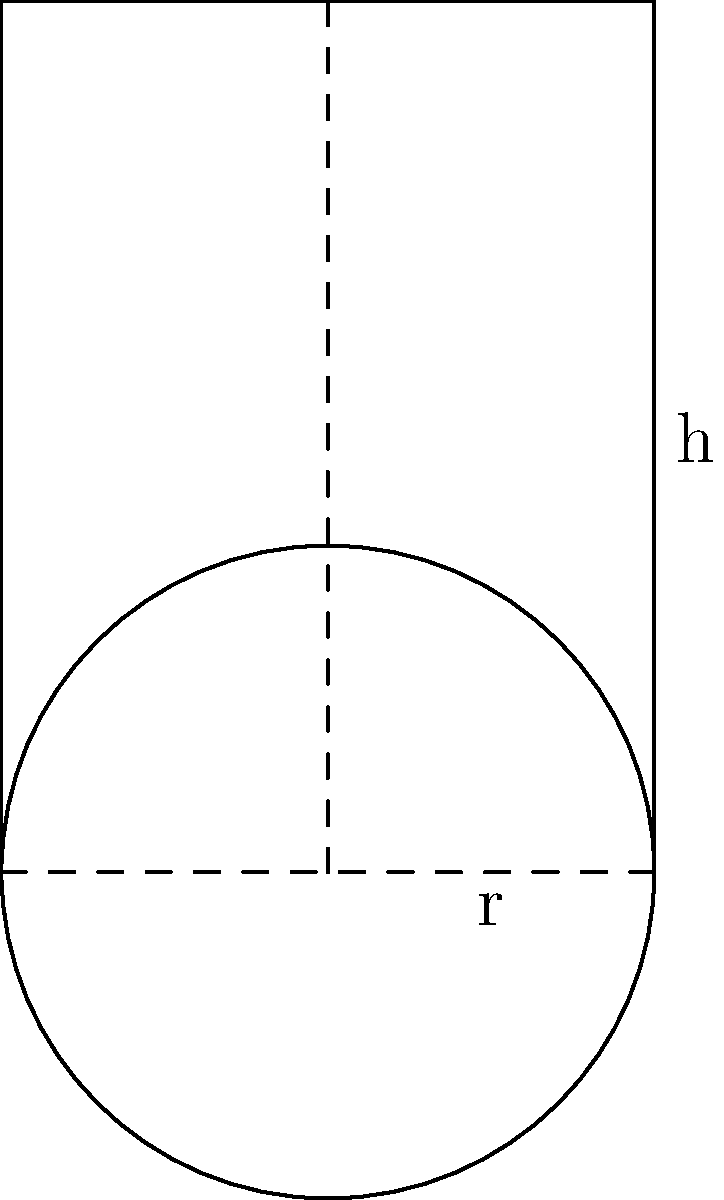You want to install a cylindrical water tank in your backyard for efficient garden watering. The tank has a radius of 0.75 meters and a height of 2 meters. Calculate the volume of water the tank can hold in liters. To solve this problem, we'll follow these steps:

1. Recall the formula for the volume of a cylinder:
   $$V = \pi r^2 h$$
   where $V$ is volume, $r$ is radius, and $h$ is height.

2. Substitute the given values:
   $r = 0.75$ meters
   $h = 2$ meters

3. Calculate the volume:
   $$V = \pi (0.75\text{ m})^2 (2\text{ m})$$
   $$V = \pi (0.5625\text{ m}^2) (2\text{ m})$$
   $$V = 3.53\text{ m}^3$$ (rounded to two decimal places)

4. Convert cubic meters to liters:
   1 cubic meter = 1000 liters
   $$3.53\text{ m}^3 \times 1000\text{ L/m}^3 = 3530\text{ L}$$

Therefore, the tank can hold approximately 3530 liters of water.
Answer: 3530 liters 